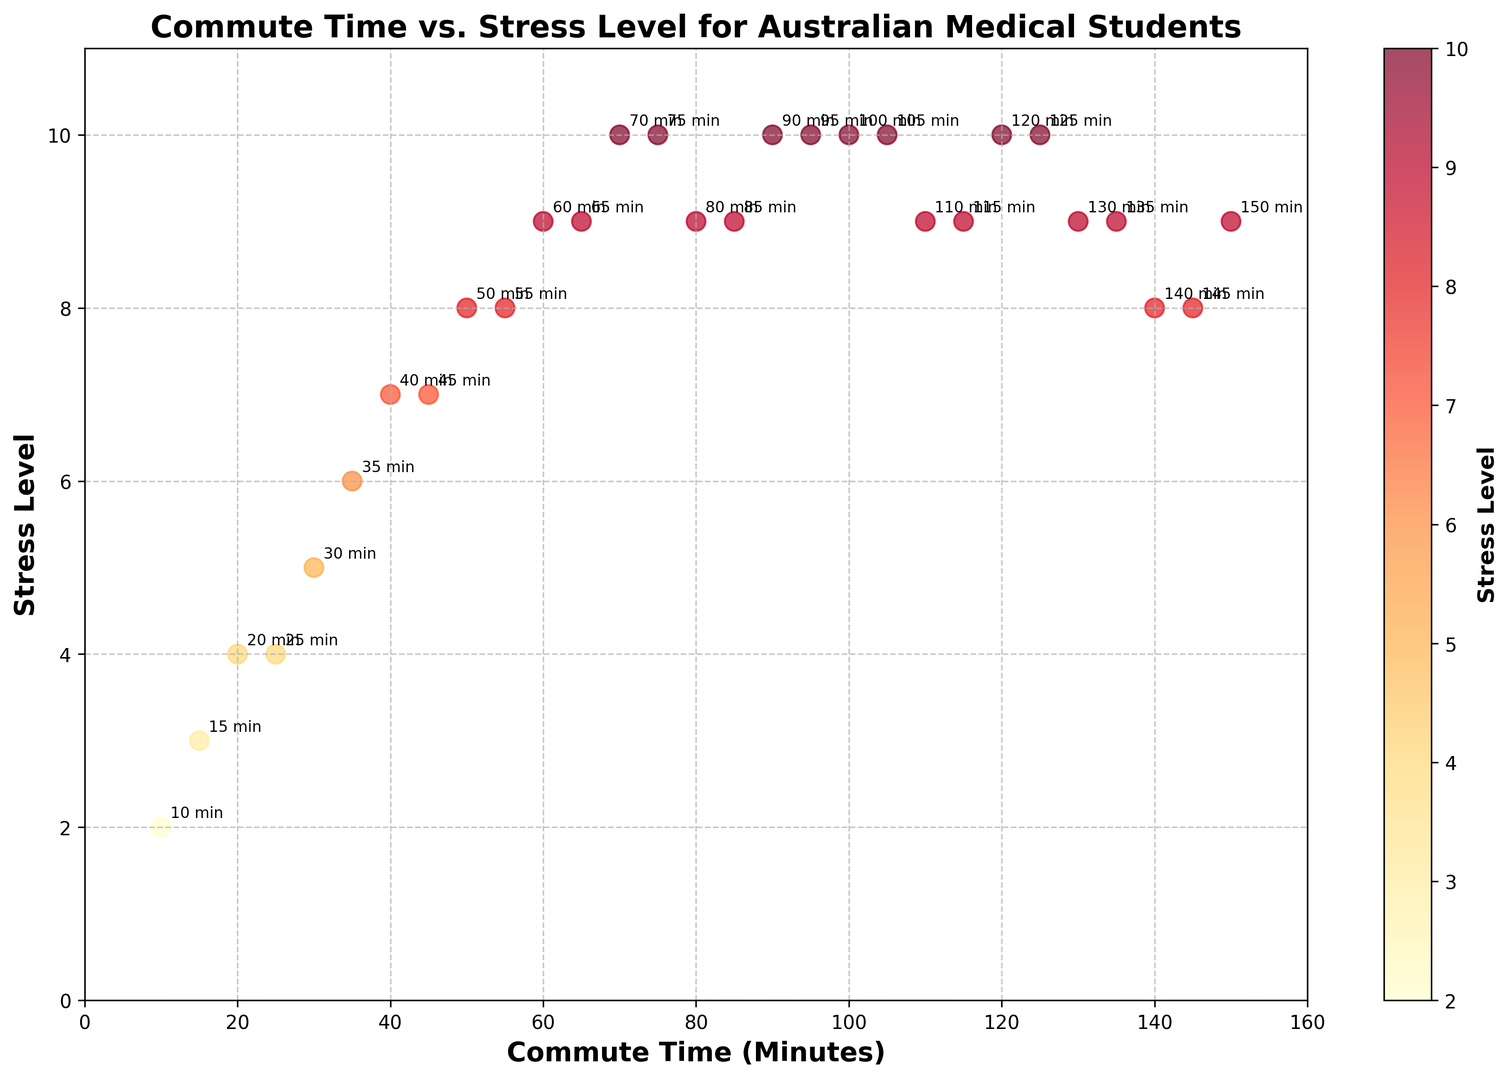What is the highest reported stress level among Australian medical students with a commute time of less than 50 minutes? The data points show that the highest reported stress level with commute times less than 50 minutes is 8 for a commute time of 40 and 45 minutes.
Answer: 8 Which commute time corresponds to a stress level of 10? By examining the scatter plot, the data points show that commute times of 70, 75, 90, 95, 100, 120, 125, and 150 minutes have a stress level of 10.
Answer: 70, 75, 90, 95, 100, 120, 125, 150 Are there commute times where the stress level is 8? By inspecting the plot, the data points indicate that the commute times of 50, 55, 140, and 145 minutes have a stress level of 8.
Answer: Yes, 50, 55, 140, 145 minutes Is there a general trend between commute time and stress level? The scatter plot shows an overall increasing trend where longer commute times generally correspond to higher stress levels among the students.
Answer: Yes What is the average stress level for commute times between 30 and 60 minutes? The commute times within this range are 30 (stress level 5), 35 (stress level 6), 40 (stress level 7), 45 (stress level 7), 50 (stress level 8), and 55 (stress level 8). The average stress level is (5+6+7+7+8+8)/6 = 41/6 ≈ 6.83.
Answer: 6.83 Compare the stress levels for students with commute times of 30 minutes and 150 minutes. Students with a 30-minute commute have a stress level of 5, and students with a 150-minute commute have a stress level of 9.
Answer: 5 vs. 9 What are the commute times with the lowest and highest stress levels? The scatter plot shows the lowest stress level is 2 at a 10-minute commute, and the highest stress level is 10 at multiple points including 70, 75, 90, 95, 100, 120, 125, and 150 minutes.
Answer: 10 minutes (lowest), multiple times including 70, 75, 90, 95, 100, 120, 125, 150 minutes (highest) Which commute times have stress levels varying the most sequentially? By examining the differences in stress levels between successive commute times, there is a significant sequential variation between 65 (stress level 9) and 70 (stress level 10).
Answer: 65 and 70 minutes 